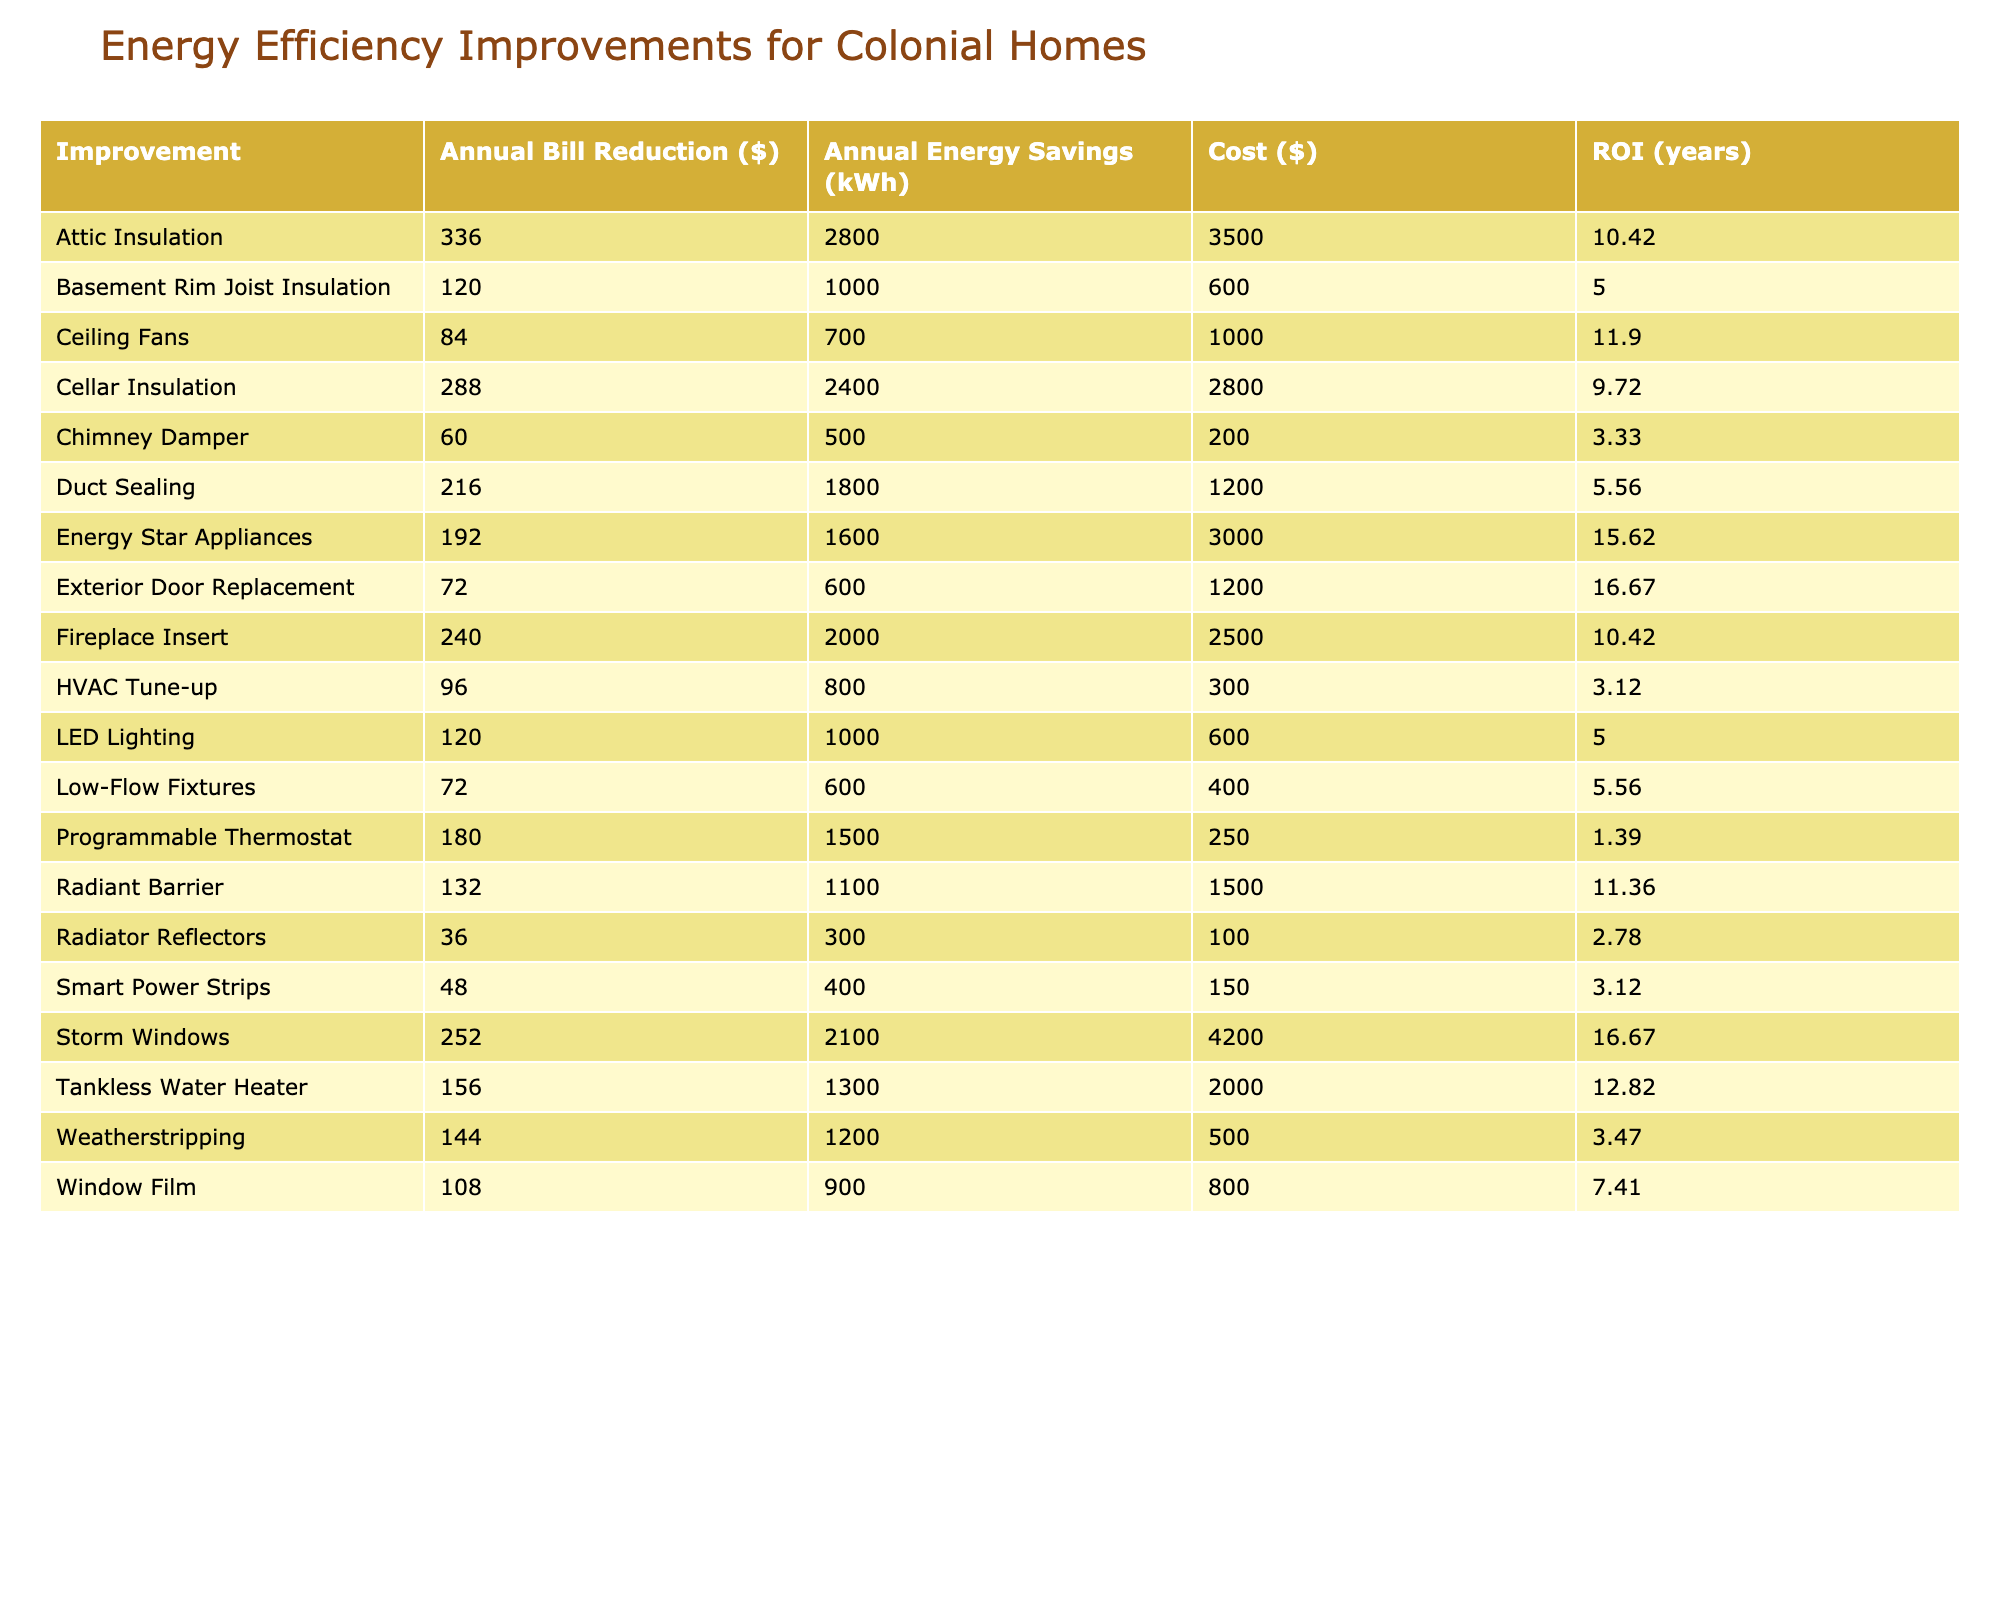What is the cost of installing storm windows? The cost of installing storm windows is listed directly in the table under the "Cost ($)" column corresponding to the row for "Storm Windows," which shows $4200.
Answer: 4200 Which improvement has the highest annual energy savings in kWh? Looking through the "Annual Energy Savings (kWh)" column, the highest value is 2800 kWh, which is associated with "Attic Insulation."
Answer: Attic Insulation Is the aesthetic impact of weatherstripping high? The table indicates that the aesthetic impact of weatherstripping is categorized as "Low," according to the "Aesthetic Impact" column.
Answer: No What is the average annual bill reduction for improvements with high historical accuracy? The improvements with high historical accuracy are Attic Insulation, Storm Windows, Weatherstripping, Duct Sealing, Chimney Damper, Radiator Reflectors, Cellar Insulation, Smart Power Strips, Low-Flow Fixtures, and Exterior Door Replacement. Adding their annual bill reductions (336 + 252 + 144 + 216 + 60 + 36 + 288 + 48 + 72 + 72 = 1296) gives a total of 1296. There are 10 improvements in this category, so the average is 1296/10 = 129.6.
Answer: 129.6 How much does the fireplace insert save annually in terms of energy costs? The "Annual Bill Reduction ($)" for the Fireplace Insert in the table is directly stated as 240 dollars, indicating the annual savings from this improvement.
Answer: 240 Which improvements have a low aesthetic impact but high historical accuracy? The table shows that Weatherstripping, Smart Power Strips, and Low-Flow Fixtures have a "Low" aesthetic impact and "High" historical accuracy according to their respective columns.
Answer: Weatherstripping, Smart Power Strips, Low-Flow Fixtures What is the total cost of all improvements listed in the table? By summing the costs of all improvements in the "Cost ($)" column, we get: 3500 + 4200 + 500 + 250 + 600 + 1200 + 200 + 100 + 2800 + 3000 + 800 + 2500 + 150 + 1000 + 400 + 2000 + 1500 + 300 + 1200 + 600 = 22850 dollars.
Answer: 22850 What is the improvement with the least annual bill reduction? Checking the "Annual Bill Reduction ($)" column, the value for "Radiator Reflectors" is the lowest at 36 dollars.
Answer: Radiator Reflectors Are tankless water heaters categorized as having a medium aesthetic impact? The table indicates that tankless water heaters are categorized with a "Medium" aesthetic impact as stated in the "Aesthetic Impact" column.
Answer: Yes 